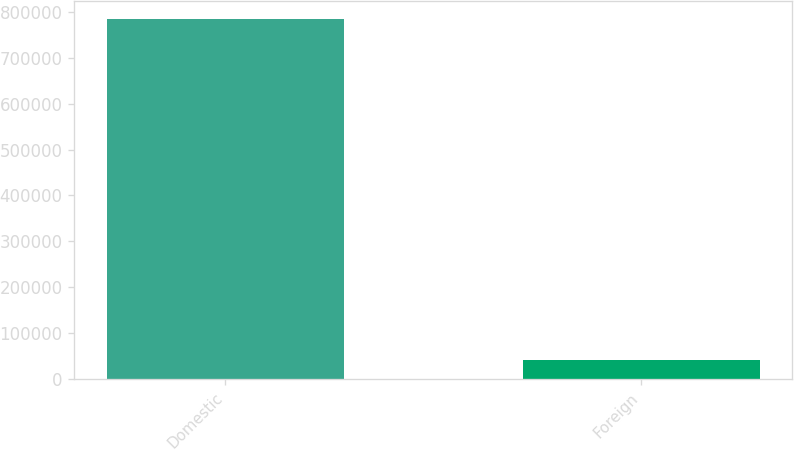<chart> <loc_0><loc_0><loc_500><loc_500><bar_chart><fcel>Domestic<fcel>Foreign<nl><fcel>785916<fcel>40104<nl></chart> 